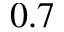<formula> <loc_0><loc_0><loc_500><loc_500>0 . 7</formula> 